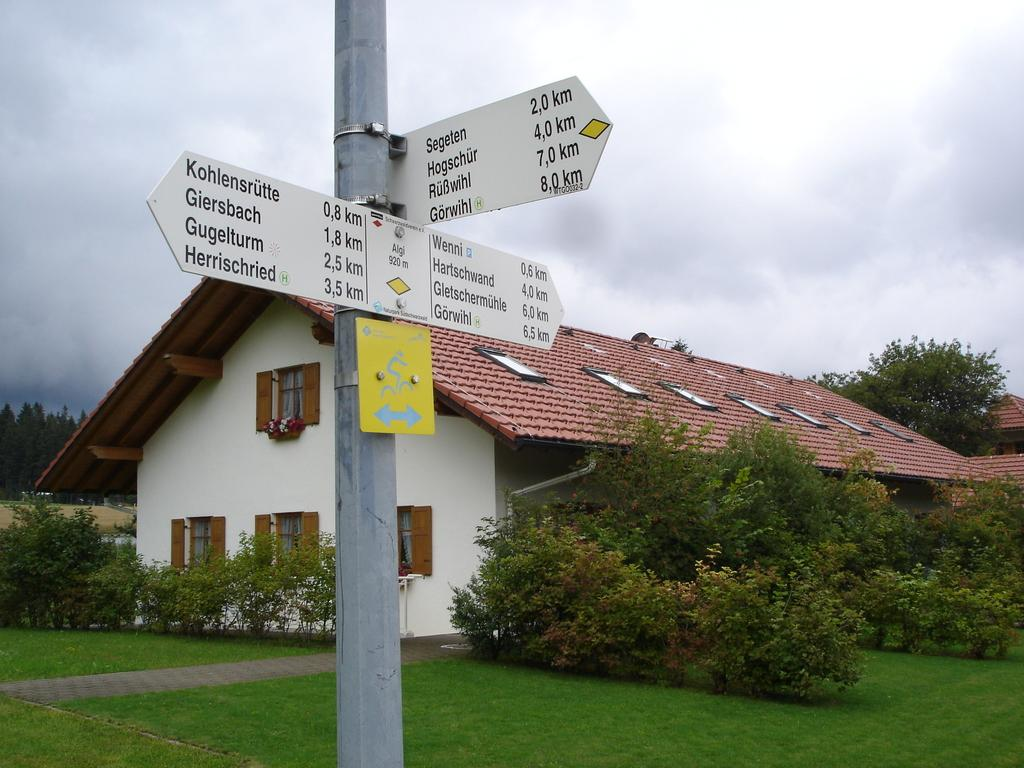<image>
Share a concise interpretation of the image provided. Signs on a post point out which direction Wenni and Segeten are in from this point. 